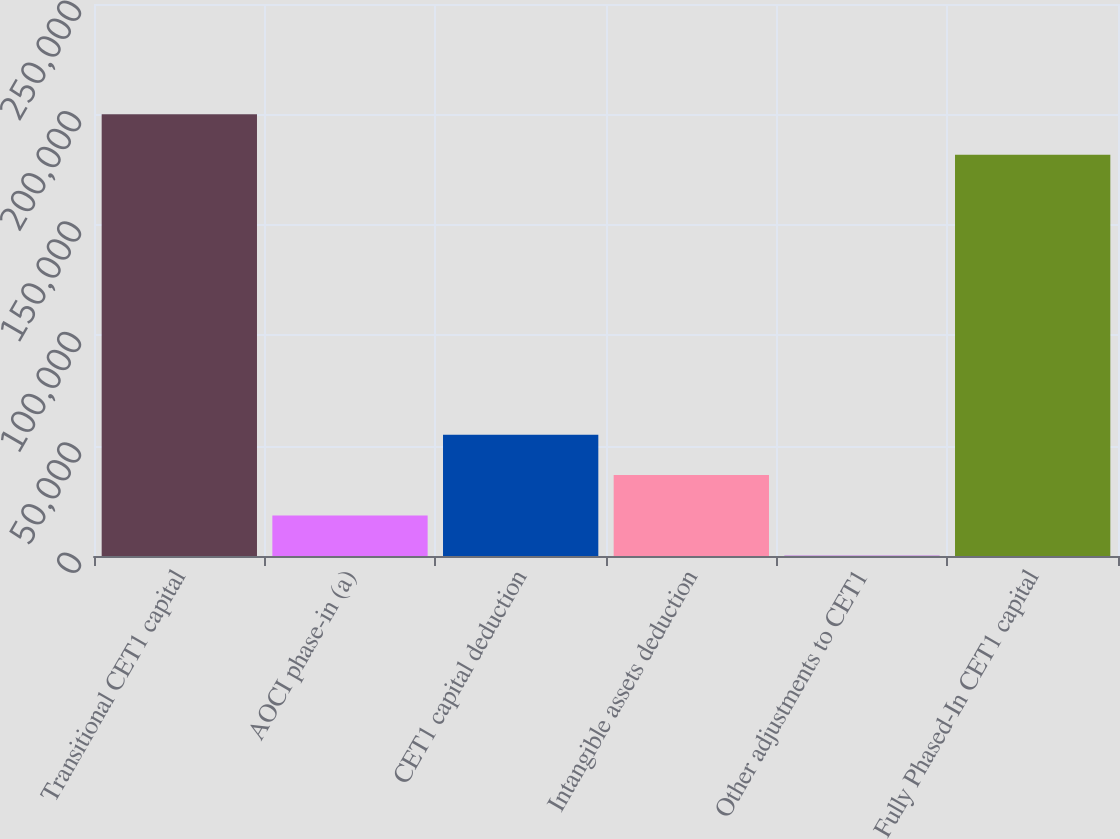<chart> <loc_0><loc_0><loc_500><loc_500><bar_chart><fcel>Transitional CET1 capital<fcel>AOCI phase-in (a)<fcel>CET1 capital deduction<fcel>Intangible assets deduction<fcel>Other adjustments to CET1<fcel>Fully Phased-In CET1 capital<nl><fcel>200024<fcel>18359.7<fcel>54939.1<fcel>36649.4<fcel>70<fcel>181734<nl></chart> 